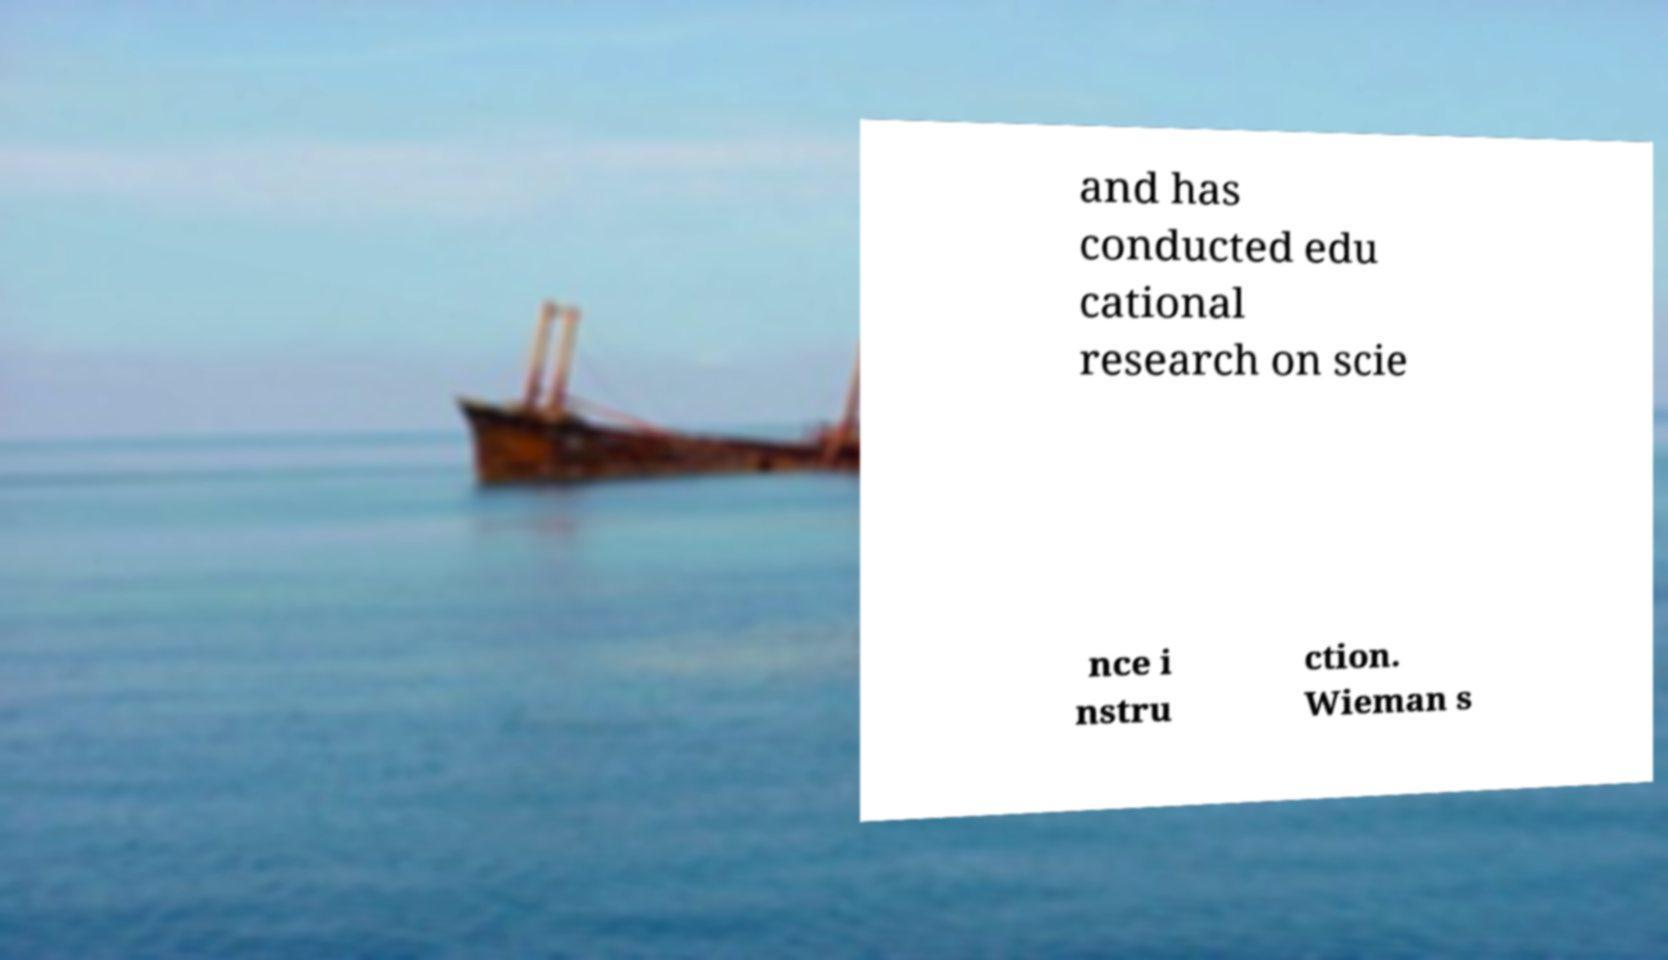I need the written content from this picture converted into text. Can you do that? and has conducted edu cational research on scie nce i nstru ction. Wieman s 